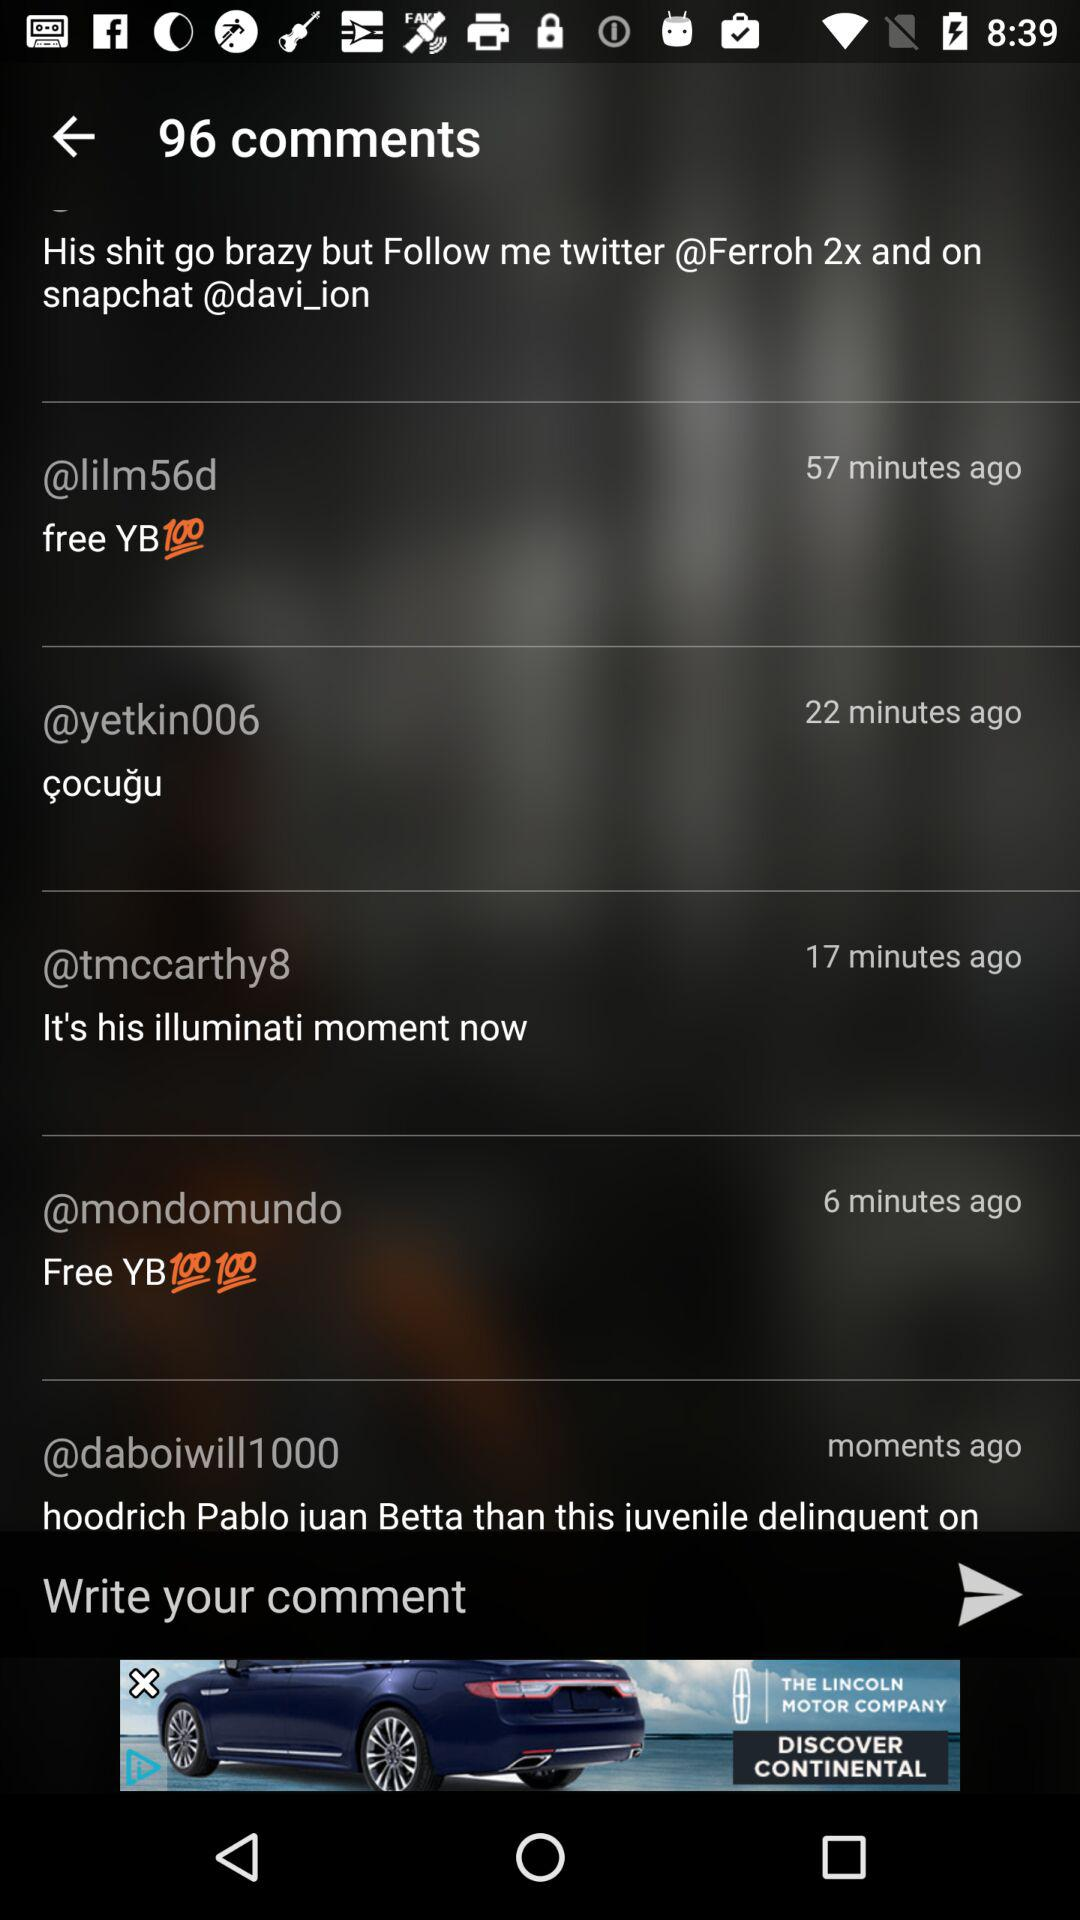How many comments are there on this video?
Answer the question using a single word or phrase. 96 